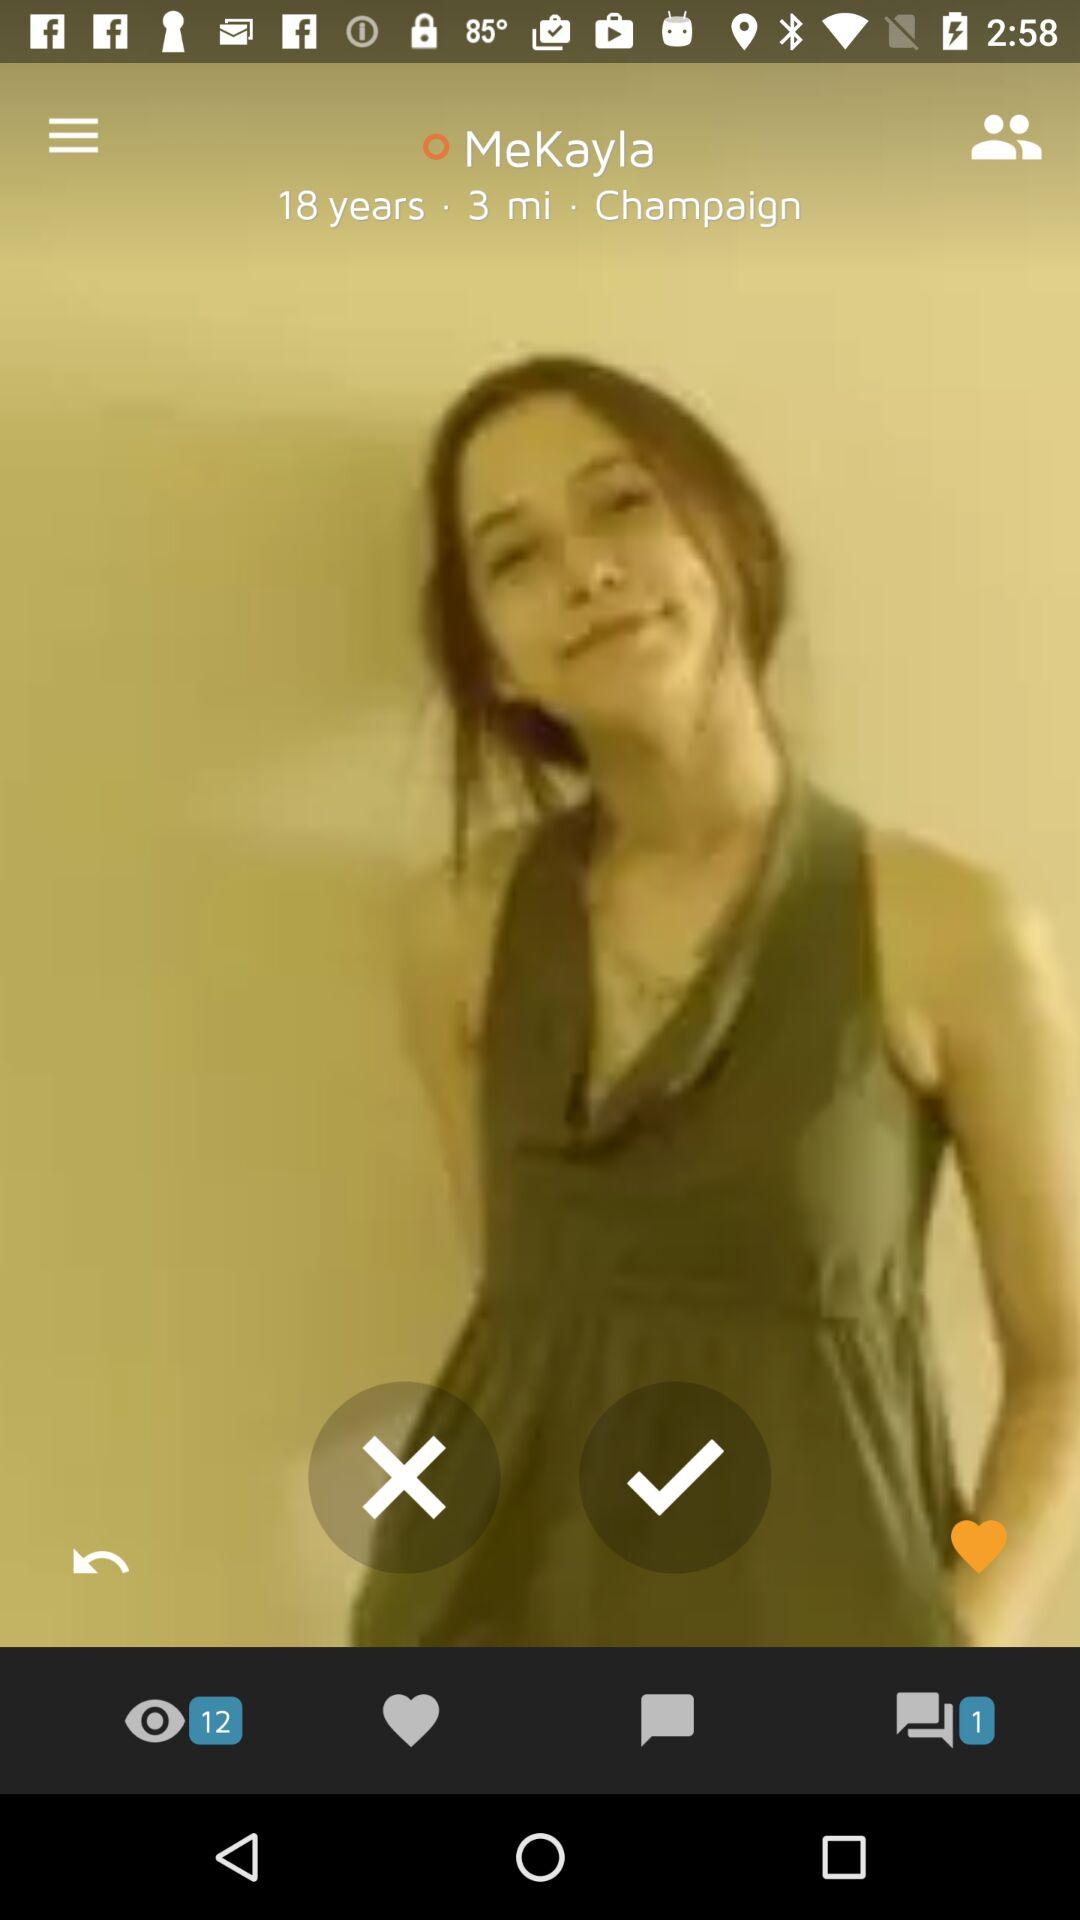How many people are in the photo?
Answer the question using a single word or phrase. 1 